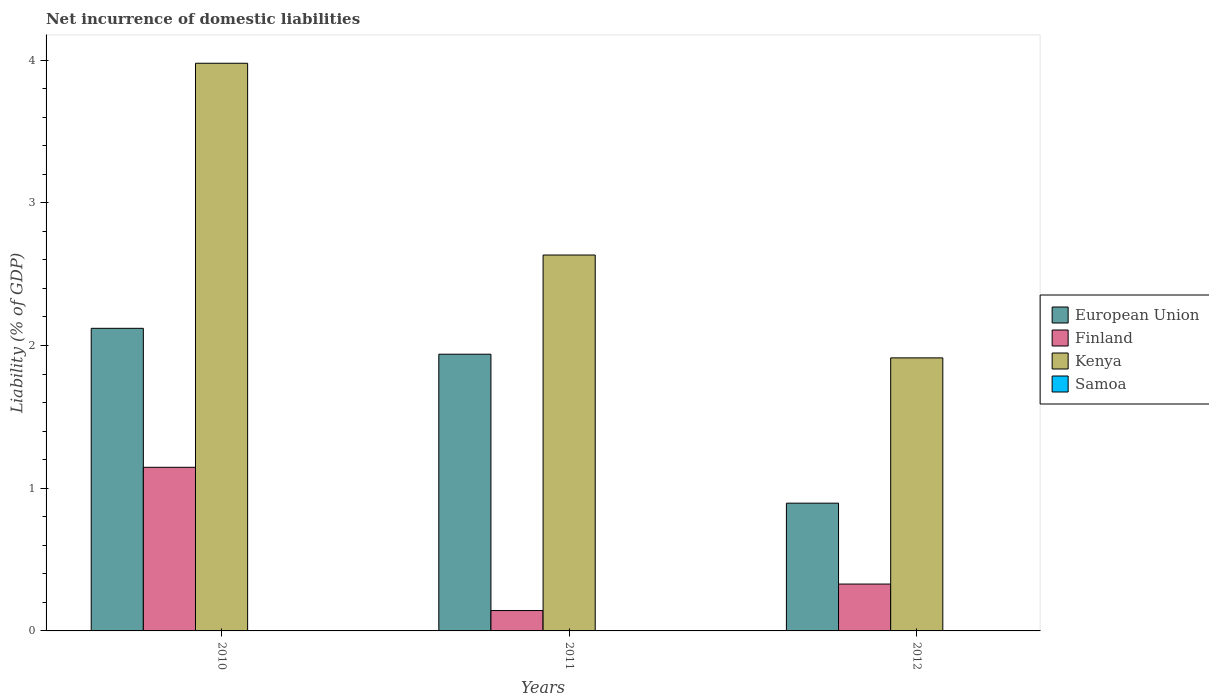How many groups of bars are there?
Provide a succinct answer. 3. Are the number of bars per tick equal to the number of legend labels?
Provide a succinct answer. No. What is the label of the 1st group of bars from the left?
Offer a terse response. 2010. What is the net incurrence of domestic liabilities in Finland in 2012?
Provide a short and direct response. 0.33. Across all years, what is the maximum net incurrence of domestic liabilities in European Union?
Provide a succinct answer. 2.12. Across all years, what is the minimum net incurrence of domestic liabilities in Finland?
Your response must be concise. 0.14. In which year was the net incurrence of domestic liabilities in European Union maximum?
Your answer should be very brief. 2010. What is the total net incurrence of domestic liabilities in Kenya in the graph?
Ensure brevity in your answer.  8.52. What is the difference between the net incurrence of domestic liabilities in Kenya in 2011 and that in 2012?
Offer a very short reply. 0.72. What is the difference between the net incurrence of domestic liabilities in European Union in 2010 and the net incurrence of domestic liabilities in Kenya in 2012?
Give a very brief answer. 0.21. What is the average net incurrence of domestic liabilities in Finland per year?
Give a very brief answer. 0.54. In the year 2012, what is the difference between the net incurrence of domestic liabilities in Kenya and net incurrence of domestic liabilities in Finland?
Your answer should be very brief. 1.58. In how many years, is the net incurrence of domestic liabilities in Finland greater than 0.8 %?
Give a very brief answer. 1. What is the ratio of the net incurrence of domestic liabilities in European Union in 2010 to that in 2011?
Keep it short and to the point. 1.09. Is the net incurrence of domestic liabilities in European Union in 2010 less than that in 2012?
Your answer should be very brief. No. Is the difference between the net incurrence of domestic liabilities in Kenya in 2010 and 2011 greater than the difference between the net incurrence of domestic liabilities in Finland in 2010 and 2011?
Your response must be concise. Yes. What is the difference between the highest and the second highest net incurrence of domestic liabilities in Finland?
Provide a short and direct response. 0.82. What is the difference between the highest and the lowest net incurrence of domestic liabilities in European Union?
Offer a terse response. 1.23. Is it the case that in every year, the sum of the net incurrence of domestic liabilities in Finland and net incurrence of domestic liabilities in Samoa is greater than the sum of net incurrence of domestic liabilities in Kenya and net incurrence of domestic liabilities in European Union?
Provide a succinct answer. No. Is it the case that in every year, the sum of the net incurrence of domestic liabilities in Finland and net incurrence of domestic liabilities in Kenya is greater than the net incurrence of domestic liabilities in Samoa?
Provide a succinct answer. Yes. Are all the bars in the graph horizontal?
Your answer should be very brief. No. How many years are there in the graph?
Make the answer very short. 3. Does the graph contain any zero values?
Your answer should be very brief. Yes. Where does the legend appear in the graph?
Your response must be concise. Center right. How many legend labels are there?
Keep it short and to the point. 4. How are the legend labels stacked?
Ensure brevity in your answer.  Vertical. What is the title of the graph?
Your answer should be very brief. Net incurrence of domestic liabilities. What is the label or title of the X-axis?
Your answer should be compact. Years. What is the label or title of the Y-axis?
Ensure brevity in your answer.  Liability (% of GDP). What is the Liability (% of GDP) of European Union in 2010?
Your response must be concise. 2.12. What is the Liability (% of GDP) in Finland in 2010?
Offer a terse response. 1.15. What is the Liability (% of GDP) of Kenya in 2010?
Offer a terse response. 3.98. What is the Liability (% of GDP) of Samoa in 2010?
Provide a succinct answer. 0. What is the Liability (% of GDP) in European Union in 2011?
Offer a terse response. 1.94. What is the Liability (% of GDP) of Finland in 2011?
Make the answer very short. 0.14. What is the Liability (% of GDP) in Kenya in 2011?
Provide a short and direct response. 2.63. What is the Liability (% of GDP) of European Union in 2012?
Your answer should be compact. 0.9. What is the Liability (% of GDP) of Finland in 2012?
Provide a short and direct response. 0.33. What is the Liability (% of GDP) in Kenya in 2012?
Your response must be concise. 1.91. What is the Liability (% of GDP) of Samoa in 2012?
Give a very brief answer. 0. Across all years, what is the maximum Liability (% of GDP) of European Union?
Give a very brief answer. 2.12. Across all years, what is the maximum Liability (% of GDP) of Finland?
Ensure brevity in your answer.  1.15. Across all years, what is the maximum Liability (% of GDP) of Kenya?
Your response must be concise. 3.98. Across all years, what is the minimum Liability (% of GDP) of European Union?
Make the answer very short. 0.9. Across all years, what is the minimum Liability (% of GDP) in Finland?
Your answer should be very brief. 0.14. Across all years, what is the minimum Liability (% of GDP) of Kenya?
Ensure brevity in your answer.  1.91. What is the total Liability (% of GDP) of European Union in the graph?
Provide a short and direct response. 4.95. What is the total Liability (% of GDP) of Finland in the graph?
Provide a succinct answer. 1.62. What is the total Liability (% of GDP) in Kenya in the graph?
Offer a very short reply. 8.52. What is the difference between the Liability (% of GDP) in European Union in 2010 and that in 2011?
Keep it short and to the point. 0.18. What is the difference between the Liability (% of GDP) of Kenya in 2010 and that in 2011?
Your answer should be very brief. 1.34. What is the difference between the Liability (% of GDP) of European Union in 2010 and that in 2012?
Make the answer very short. 1.23. What is the difference between the Liability (% of GDP) of Finland in 2010 and that in 2012?
Your response must be concise. 0.82. What is the difference between the Liability (% of GDP) of Kenya in 2010 and that in 2012?
Your response must be concise. 2.06. What is the difference between the Liability (% of GDP) in European Union in 2011 and that in 2012?
Your response must be concise. 1.04. What is the difference between the Liability (% of GDP) in Finland in 2011 and that in 2012?
Your answer should be compact. -0.19. What is the difference between the Liability (% of GDP) in Kenya in 2011 and that in 2012?
Offer a terse response. 0.72. What is the difference between the Liability (% of GDP) of European Union in 2010 and the Liability (% of GDP) of Finland in 2011?
Offer a terse response. 1.98. What is the difference between the Liability (% of GDP) of European Union in 2010 and the Liability (% of GDP) of Kenya in 2011?
Keep it short and to the point. -0.51. What is the difference between the Liability (% of GDP) of Finland in 2010 and the Liability (% of GDP) of Kenya in 2011?
Offer a very short reply. -1.49. What is the difference between the Liability (% of GDP) in European Union in 2010 and the Liability (% of GDP) in Finland in 2012?
Offer a terse response. 1.79. What is the difference between the Liability (% of GDP) of European Union in 2010 and the Liability (% of GDP) of Kenya in 2012?
Keep it short and to the point. 0.21. What is the difference between the Liability (% of GDP) in Finland in 2010 and the Liability (% of GDP) in Kenya in 2012?
Give a very brief answer. -0.77. What is the difference between the Liability (% of GDP) of European Union in 2011 and the Liability (% of GDP) of Finland in 2012?
Your answer should be very brief. 1.61. What is the difference between the Liability (% of GDP) in European Union in 2011 and the Liability (% of GDP) in Kenya in 2012?
Provide a succinct answer. 0.03. What is the difference between the Liability (% of GDP) in Finland in 2011 and the Liability (% of GDP) in Kenya in 2012?
Provide a succinct answer. -1.77. What is the average Liability (% of GDP) in European Union per year?
Give a very brief answer. 1.65. What is the average Liability (% of GDP) in Finland per year?
Provide a succinct answer. 0.54. What is the average Liability (% of GDP) in Kenya per year?
Your answer should be compact. 2.84. In the year 2010, what is the difference between the Liability (% of GDP) of European Union and Liability (% of GDP) of Finland?
Your answer should be compact. 0.97. In the year 2010, what is the difference between the Liability (% of GDP) of European Union and Liability (% of GDP) of Kenya?
Provide a short and direct response. -1.86. In the year 2010, what is the difference between the Liability (% of GDP) in Finland and Liability (% of GDP) in Kenya?
Make the answer very short. -2.83. In the year 2011, what is the difference between the Liability (% of GDP) in European Union and Liability (% of GDP) in Finland?
Provide a succinct answer. 1.8. In the year 2011, what is the difference between the Liability (% of GDP) in European Union and Liability (% of GDP) in Kenya?
Your answer should be compact. -0.69. In the year 2011, what is the difference between the Liability (% of GDP) in Finland and Liability (% of GDP) in Kenya?
Provide a short and direct response. -2.49. In the year 2012, what is the difference between the Liability (% of GDP) of European Union and Liability (% of GDP) of Finland?
Make the answer very short. 0.57. In the year 2012, what is the difference between the Liability (% of GDP) in European Union and Liability (% of GDP) in Kenya?
Ensure brevity in your answer.  -1.02. In the year 2012, what is the difference between the Liability (% of GDP) in Finland and Liability (% of GDP) in Kenya?
Offer a terse response. -1.58. What is the ratio of the Liability (% of GDP) in European Union in 2010 to that in 2011?
Offer a terse response. 1.09. What is the ratio of the Liability (% of GDP) in Finland in 2010 to that in 2011?
Give a very brief answer. 8.03. What is the ratio of the Liability (% of GDP) in Kenya in 2010 to that in 2011?
Your answer should be very brief. 1.51. What is the ratio of the Liability (% of GDP) in European Union in 2010 to that in 2012?
Your answer should be compact. 2.37. What is the ratio of the Liability (% of GDP) of Finland in 2010 to that in 2012?
Offer a very short reply. 3.49. What is the ratio of the Liability (% of GDP) of Kenya in 2010 to that in 2012?
Make the answer very short. 2.08. What is the ratio of the Liability (% of GDP) of European Union in 2011 to that in 2012?
Keep it short and to the point. 2.17. What is the ratio of the Liability (% of GDP) of Finland in 2011 to that in 2012?
Offer a very short reply. 0.43. What is the ratio of the Liability (% of GDP) of Kenya in 2011 to that in 2012?
Your response must be concise. 1.38. What is the difference between the highest and the second highest Liability (% of GDP) in European Union?
Your answer should be compact. 0.18. What is the difference between the highest and the second highest Liability (% of GDP) of Finland?
Keep it short and to the point. 0.82. What is the difference between the highest and the second highest Liability (% of GDP) of Kenya?
Offer a terse response. 1.34. What is the difference between the highest and the lowest Liability (% of GDP) of European Union?
Keep it short and to the point. 1.23. What is the difference between the highest and the lowest Liability (% of GDP) in Finland?
Your answer should be compact. 1. What is the difference between the highest and the lowest Liability (% of GDP) in Kenya?
Provide a short and direct response. 2.06. 